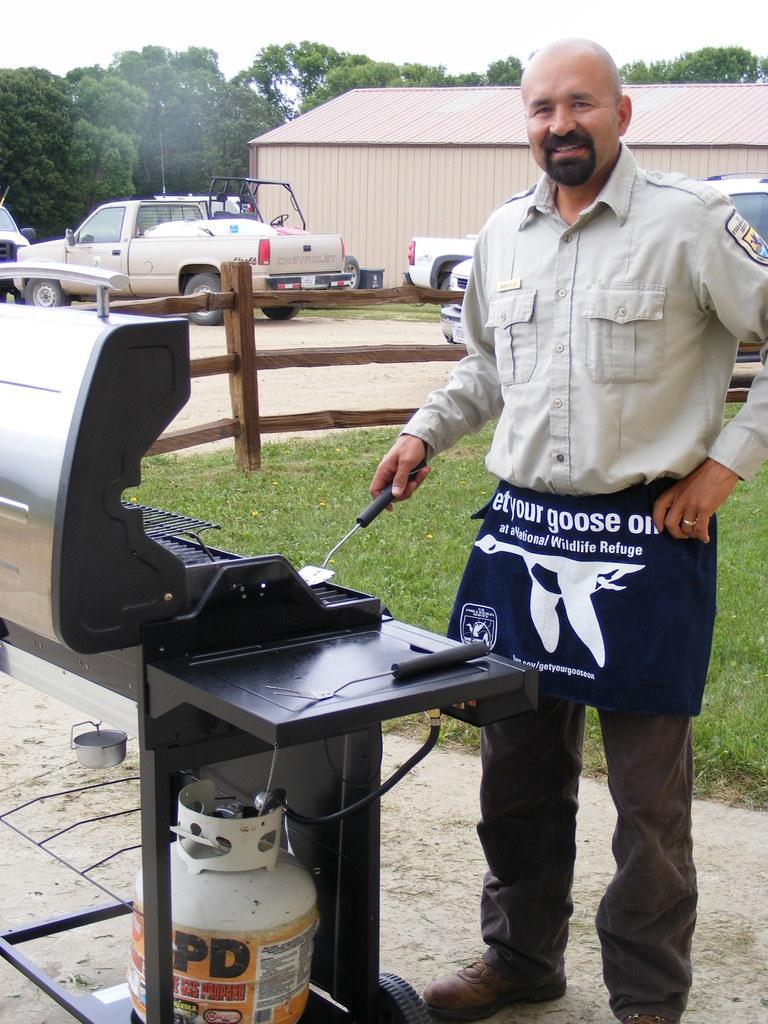<image>
Describe the image concisely. A man wearing an apron that says get your goose on. 